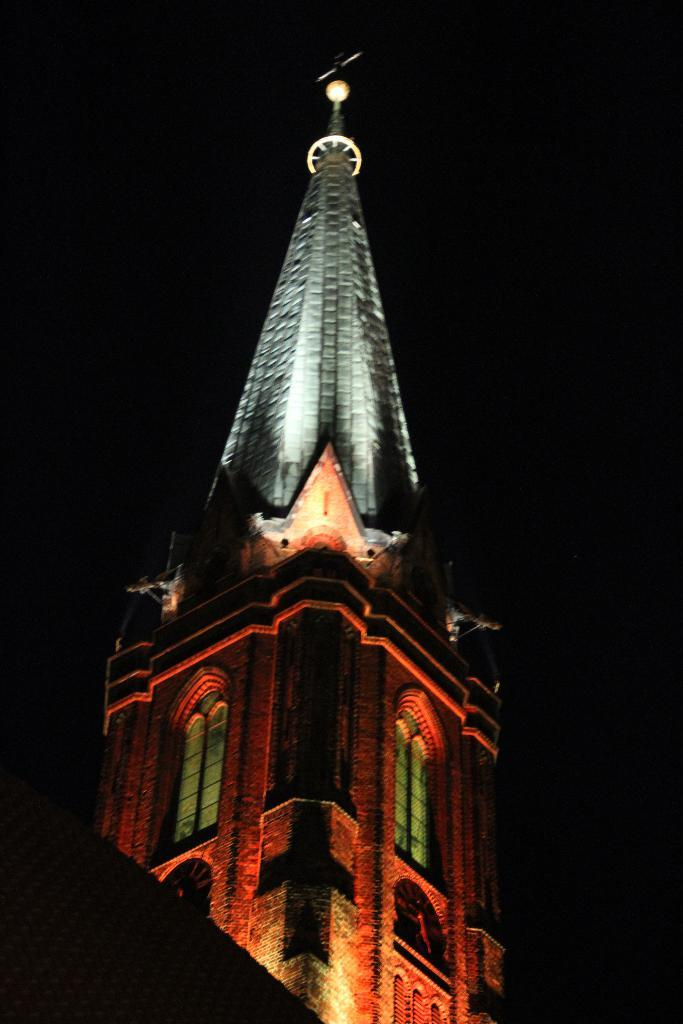What is the main subject of the image? The main subject of the image is a tower. What specific features can be observed on the tower? The tower has windows. What color is the background of the image? The background of the image is black. What type of steel is used to construct the tower in the image? There is no information about the type of steel used to construct the tower in the image. How much power is generated by the tower in the image? The image does not provide any information about the tower generating power. 